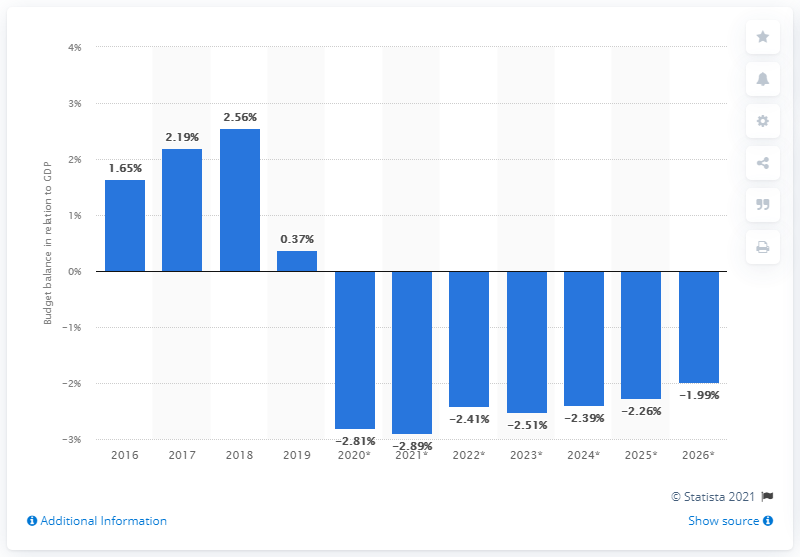Identify some key points in this picture. In 2019, South Korea's budget surplus represented approximately 0.37% of its Gross Domestic Product. 